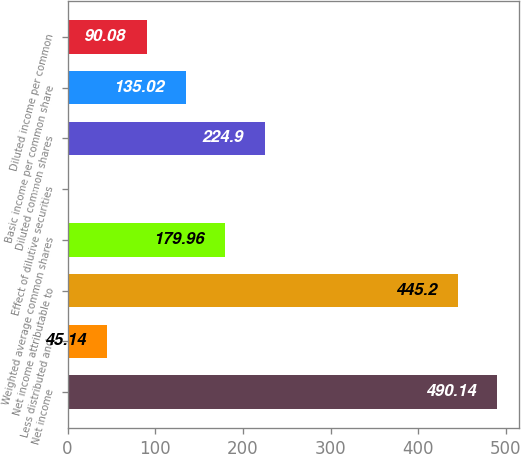<chart> <loc_0><loc_0><loc_500><loc_500><bar_chart><fcel>Net income<fcel>Less distributed and<fcel>Net income attributable to<fcel>Weighted average common shares<fcel>Effect of dilutive securities<fcel>Diluted common shares<fcel>Basic income per common share<fcel>Diluted income per common<nl><fcel>490.14<fcel>45.14<fcel>445.2<fcel>179.96<fcel>0.2<fcel>224.9<fcel>135.02<fcel>90.08<nl></chart> 